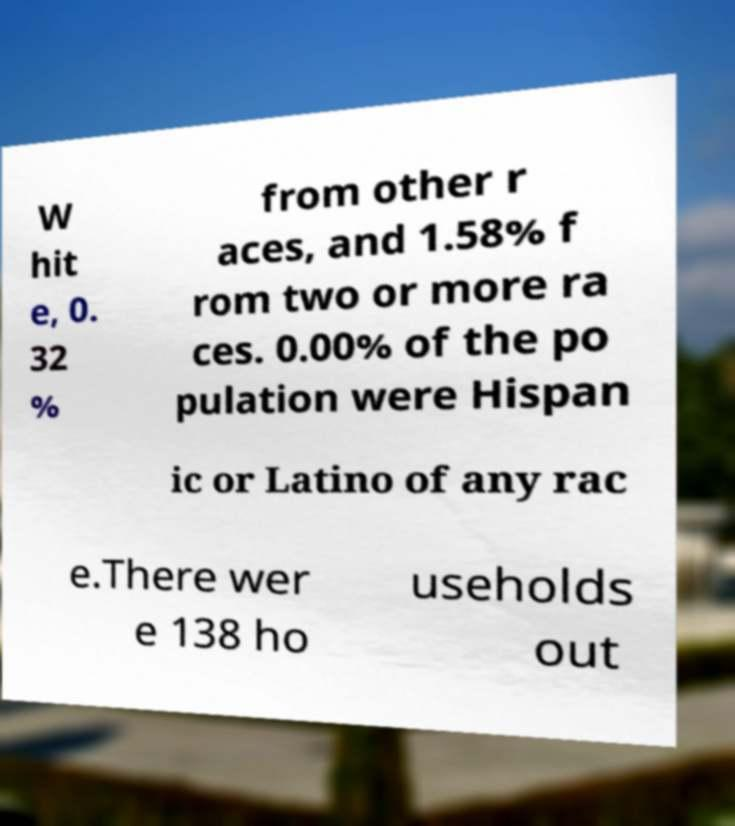For documentation purposes, I need the text within this image transcribed. Could you provide that? W hit e, 0. 32 % from other r aces, and 1.58% f rom two or more ra ces. 0.00% of the po pulation were Hispan ic or Latino of any rac e.There wer e 138 ho useholds out 